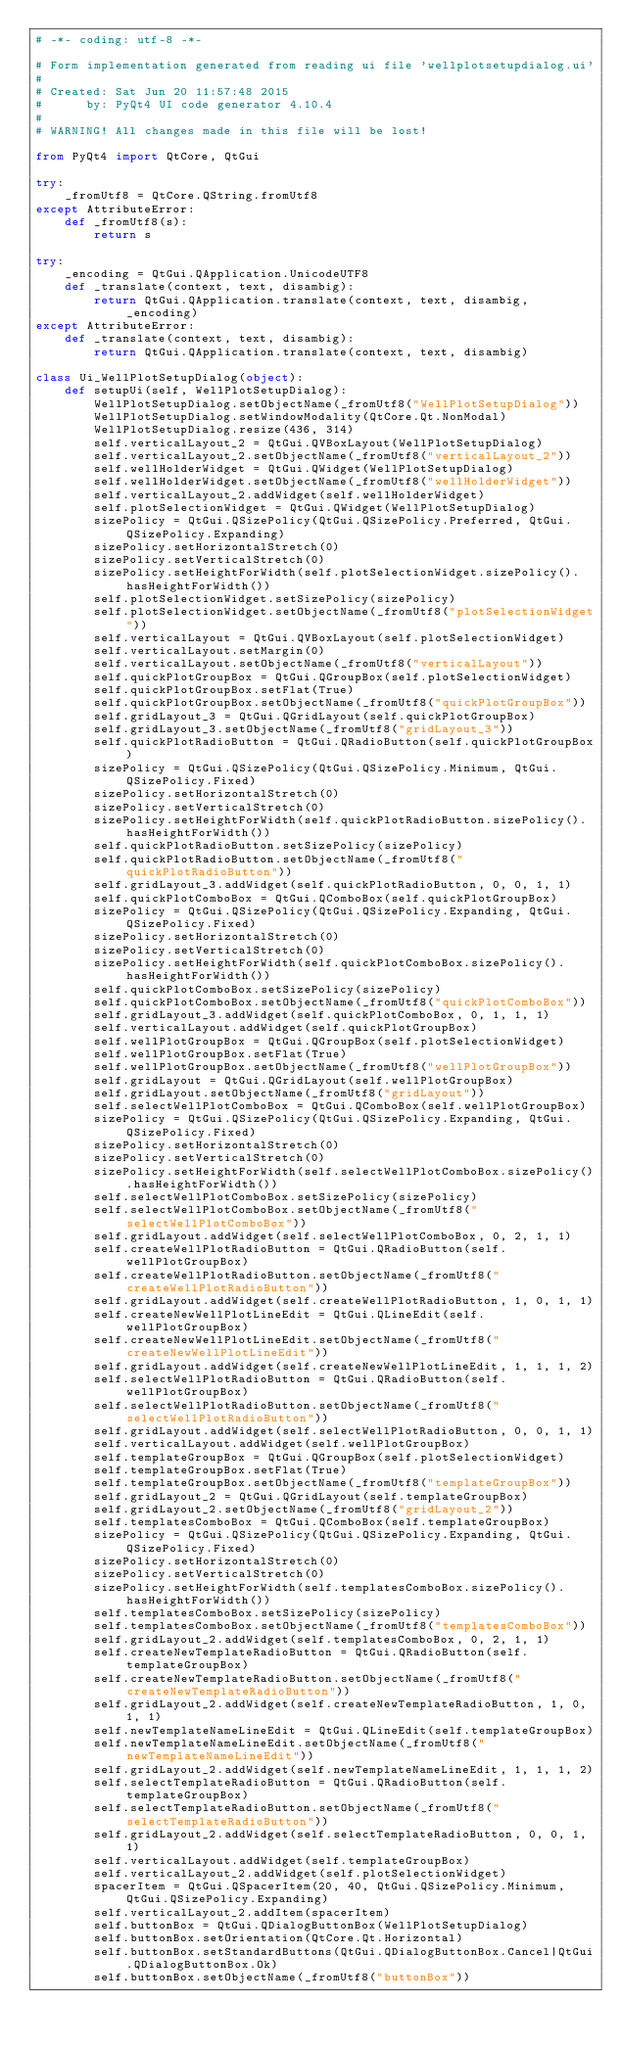<code> <loc_0><loc_0><loc_500><loc_500><_Python_># -*- coding: utf-8 -*-

# Form implementation generated from reading ui file 'wellplotsetupdialog.ui'
#
# Created: Sat Jun 20 11:57:48 2015
#      by: PyQt4 UI code generator 4.10.4
#
# WARNING! All changes made in this file will be lost!

from PyQt4 import QtCore, QtGui

try:
    _fromUtf8 = QtCore.QString.fromUtf8
except AttributeError:
    def _fromUtf8(s):
        return s

try:
    _encoding = QtGui.QApplication.UnicodeUTF8
    def _translate(context, text, disambig):
        return QtGui.QApplication.translate(context, text, disambig, _encoding)
except AttributeError:
    def _translate(context, text, disambig):
        return QtGui.QApplication.translate(context, text, disambig)

class Ui_WellPlotSetupDialog(object):
    def setupUi(self, WellPlotSetupDialog):
        WellPlotSetupDialog.setObjectName(_fromUtf8("WellPlotSetupDialog"))
        WellPlotSetupDialog.setWindowModality(QtCore.Qt.NonModal)
        WellPlotSetupDialog.resize(436, 314)
        self.verticalLayout_2 = QtGui.QVBoxLayout(WellPlotSetupDialog)
        self.verticalLayout_2.setObjectName(_fromUtf8("verticalLayout_2"))
        self.wellHolderWidget = QtGui.QWidget(WellPlotSetupDialog)
        self.wellHolderWidget.setObjectName(_fromUtf8("wellHolderWidget"))
        self.verticalLayout_2.addWidget(self.wellHolderWidget)
        self.plotSelectionWidget = QtGui.QWidget(WellPlotSetupDialog)
        sizePolicy = QtGui.QSizePolicy(QtGui.QSizePolicy.Preferred, QtGui.QSizePolicy.Expanding)
        sizePolicy.setHorizontalStretch(0)
        sizePolicy.setVerticalStretch(0)
        sizePolicy.setHeightForWidth(self.plotSelectionWidget.sizePolicy().hasHeightForWidth())
        self.plotSelectionWidget.setSizePolicy(sizePolicy)
        self.plotSelectionWidget.setObjectName(_fromUtf8("plotSelectionWidget"))
        self.verticalLayout = QtGui.QVBoxLayout(self.plotSelectionWidget)
        self.verticalLayout.setMargin(0)
        self.verticalLayout.setObjectName(_fromUtf8("verticalLayout"))
        self.quickPlotGroupBox = QtGui.QGroupBox(self.plotSelectionWidget)
        self.quickPlotGroupBox.setFlat(True)
        self.quickPlotGroupBox.setObjectName(_fromUtf8("quickPlotGroupBox"))
        self.gridLayout_3 = QtGui.QGridLayout(self.quickPlotGroupBox)
        self.gridLayout_3.setObjectName(_fromUtf8("gridLayout_3"))
        self.quickPlotRadioButton = QtGui.QRadioButton(self.quickPlotGroupBox)
        sizePolicy = QtGui.QSizePolicy(QtGui.QSizePolicy.Minimum, QtGui.QSizePolicy.Fixed)
        sizePolicy.setHorizontalStretch(0)
        sizePolicy.setVerticalStretch(0)
        sizePolicy.setHeightForWidth(self.quickPlotRadioButton.sizePolicy().hasHeightForWidth())
        self.quickPlotRadioButton.setSizePolicy(sizePolicy)
        self.quickPlotRadioButton.setObjectName(_fromUtf8("quickPlotRadioButton"))
        self.gridLayout_3.addWidget(self.quickPlotRadioButton, 0, 0, 1, 1)
        self.quickPlotComboBox = QtGui.QComboBox(self.quickPlotGroupBox)
        sizePolicy = QtGui.QSizePolicy(QtGui.QSizePolicy.Expanding, QtGui.QSizePolicy.Fixed)
        sizePolicy.setHorizontalStretch(0)
        sizePolicy.setVerticalStretch(0)
        sizePolicy.setHeightForWidth(self.quickPlotComboBox.sizePolicy().hasHeightForWidth())
        self.quickPlotComboBox.setSizePolicy(sizePolicy)
        self.quickPlotComboBox.setObjectName(_fromUtf8("quickPlotComboBox"))
        self.gridLayout_3.addWidget(self.quickPlotComboBox, 0, 1, 1, 1)
        self.verticalLayout.addWidget(self.quickPlotGroupBox)
        self.wellPlotGroupBox = QtGui.QGroupBox(self.plotSelectionWidget)
        self.wellPlotGroupBox.setFlat(True)
        self.wellPlotGroupBox.setObjectName(_fromUtf8("wellPlotGroupBox"))
        self.gridLayout = QtGui.QGridLayout(self.wellPlotGroupBox)
        self.gridLayout.setObjectName(_fromUtf8("gridLayout"))
        self.selectWellPlotComboBox = QtGui.QComboBox(self.wellPlotGroupBox)
        sizePolicy = QtGui.QSizePolicy(QtGui.QSizePolicy.Expanding, QtGui.QSizePolicy.Fixed)
        sizePolicy.setHorizontalStretch(0)
        sizePolicy.setVerticalStretch(0)
        sizePolicy.setHeightForWidth(self.selectWellPlotComboBox.sizePolicy().hasHeightForWidth())
        self.selectWellPlotComboBox.setSizePolicy(sizePolicy)
        self.selectWellPlotComboBox.setObjectName(_fromUtf8("selectWellPlotComboBox"))
        self.gridLayout.addWidget(self.selectWellPlotComboBox, 0, 2, 1, 1)
        self.createWellPlotRadioButton = QtGui.QRadioButton(self.wellPlotGroupBox)
        self.createWellPlotRadioButton.setObjectName(_fromUtf8("createWellPlotRadioButton"))
        self.gridLayout.addWidget(self.createWellPlotRadioButton, 1, 0, 1, 1)
        self.createNewWellPlotLineEdit = QtGui.QLineEdit(self.wellPlotGroupBox)
        self.createNewWellPlotLineEdit.setObjectName(_fromUtf8("createNewWellPlotLineEdit"))
        self.gridLayout.addWidget(self.createNewWellPlotLineEdit, 1, 1, 1, 2)
        self.selectWellPlotRadioButton = QtGui.QRadioButton(self.wellPlotGroupBox)
        self.selectWellPlotRadioButton.setObjectName(_fromUtf8("selectWellPlotRadioButton"))
        self.gridLayout.addWidget(self.selectWellPlotRadioButton, 0, 0, 1, 1)
        self.verticalLayout.addWidget(self.wellPlotGroupBox)
        self.templateGroupBox = QtGui.QGroupBox(self.plotSelectionWidget)
        self.templateGroupBox.setFlat(True)
        self.templateGroupBox.setObjectName(_fromUtf8("templateGroupBox"))
        self.gridLayout_2 = QtGui.QGridLayout(self.templateGroupBox)
        self.gridLayout_2.setObjectName(_fromUtf8("gridLayout_2"))
        self.templatesComboBox = QtGui.QComboBox(self.templateGroupBox)
        sizePolicy = QtGui.QSizePolicy(QtGui.QSizePolicy.Expanding, QtGui.QSizePolicy.Fixed)
        sizePolicy.setHorizontalStretch(0)
        sizePolicy.setVerticalStretch(0)
        sizePolicy.setHeightForWidth(self.templatesComboBox.sizePolicy().hasHeightForWidth())
        self.templatesComboBox.setSizePolicy(sizePolicy)
        self.templatesComboBox.setObjectName(_fromUtf8("templatesComboBox"))
        self.gridLayout_2.addWidget(self.templatesComboBox, 0, 2, 1, 1)
        self.createNewTemplateRadioButton = QtGui.QRadioButton(self.templateGroupBox)
        self.createNewTemplateRadioButton.setObjectName(_fromUtf8("createNewTemplateRadioButton"))
        self.gridLayout_2.addWidget(self.createNewTemplateRadioButton, 1, 0, 1, 1)
        self.newTemplateNameLineEdit = QtGui.QLineEdit(self.templateGroupBox)
        self.newTemplateNameLineEdit.setObjectName(_fromUtf8("newTemplateNameLineEdit"))
        self.gridLayout_2.addWidget(self.newTemplateNameLineEdit, 1, 1, 1, 2)
        self.selectTemplateRadioButton = QtGui.QRadioButton(self.templateGroupBox)
        self.selectTemplateRadioButton.setObjectName(_fromUtf8("selectTemplateRadioButton"))
        self.gridLayout_2.addWidget(self.selectTemplateRadioButton, 0, 0, 1, 1)
        self.verticalLayout.addWidget(self.templateGroupBox)
        self.verticalLayout_2.addWidget(self.plotSelectionWidget)
        spacerItem = QtGui.QSpacerItem(20, 40, QtGui.QSizePolicy.Minimum, QtGui.QSizePolicy.Expanding)
        self.verticalLayout_2.addItem(spacerItem)
        self.buttonBox = QtGui.QDialogButtonBox(WellPlotSetupDialog)
        self.buttonBox.setOrientation(QtCore.Qt.Horizontal)
        self.buttonBox.setStandardButtons(QtGui.QDialogButtonBox.Cancel|QtGui.QDialogButtonBox.Ok)
        self.buttonBox.setObjectName(_fromUtf8("buttonBox"))</code> 